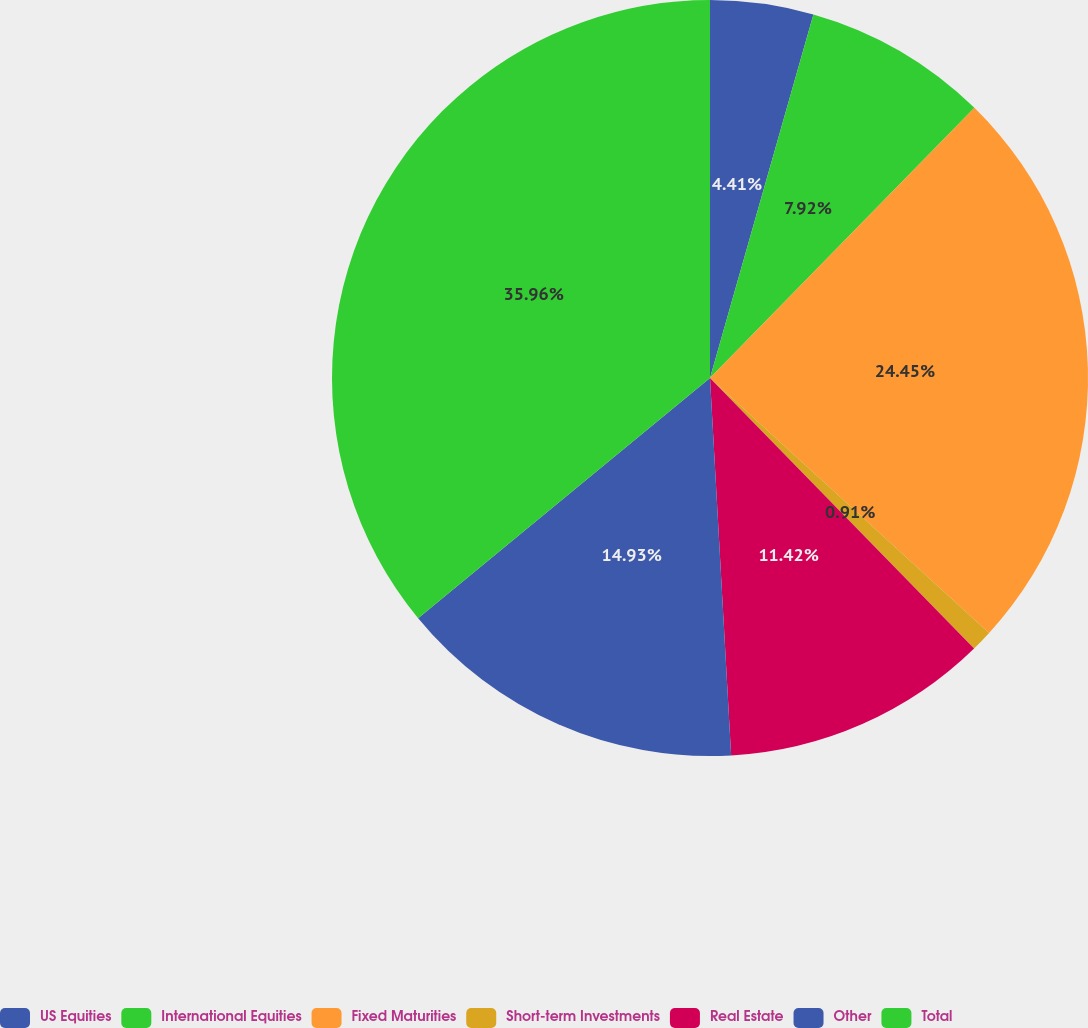<chart> <loc_0><loc_0><loc_500><loc_500><pie_chart><fcel>US Equities<fcel>International Equities<fcel>Fixed Maturities<fcel>Short-term Investments<fcel>Real Estate<fcel>Other<fcel>Total<nl><fcel>4.41%<fcel>7.92%<fcel>24.45%<fcel>0.91%<fcel>11.42%<fcel>14.93%<fcel>35.96%<nl></chart> 